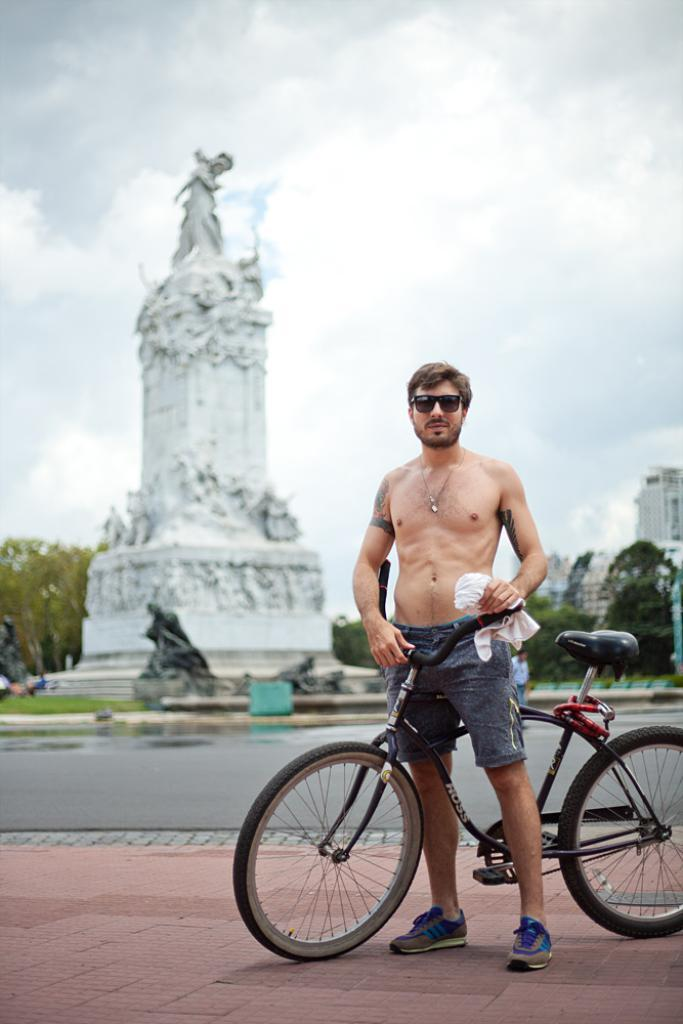What is the person holding in their hand in the image? The person is holding a bicycle in their hand. What can be seen behind the person? There is a statue and trees visible behind the person. What type of structures are in the background of the image? There are buildings in the background. How would you describe the sky in the image? The sky is cloudy in the image. What type of fact can be seen on the flag in the image? There is no flag present in the image, so it is not possible to determine what type of fact might be seen on it. 